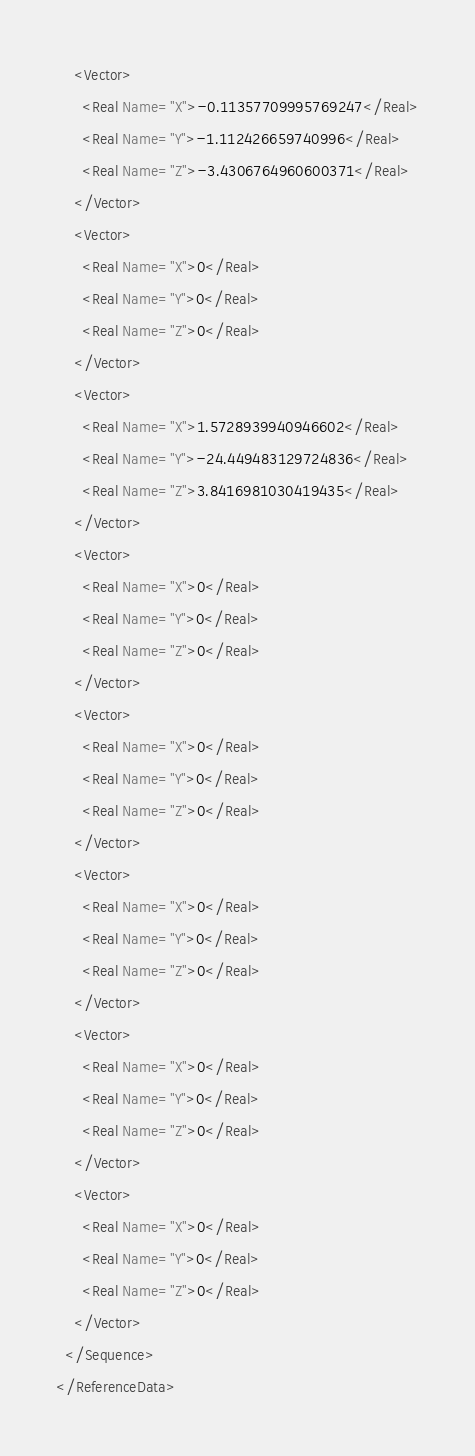Convert code to text. <code><loc_0><loc_0><loc_500><loc_500><_XML_>    <Vector>
      <Real Name="X">-0.11357709995769247</Real>
      <Real Name="Y">-1.112426659740996</Real>
      <Real Name="Z">-3.4306764960600371</Real>
    </Vector>
    <Vector>
      <Real Name="X">0</Real>
      <Real Name="Y">0</Real>
      <Real Name="Z">0</Real>
    </Vector>
    <Vector>
      <Real Name="X">1.5728939940946602</Real>
      <Real Name="Y">-24.449483129724836</Real>
      <Real Name="Z">3.8416981030419435</Real>
    </Vector>
    <Vector>
      <Real Name="X">0</Real>
      <Real Name="Y">0</Real>
      <Real Name="Z">0</Real>
    </Vector>
    <Vector>
      <Real Name="X">0</Real>
      <Real Name="Y">0</Real>
      <Real Name="Z">0</Real>
    </Vector>
    <Vector>
      <Real Name="X">0</Real>
      <Real Name="Y">0</Real>
      <Real Name="Z">0</Real>
    </Vector>
    <Vector>
      <Real Name="X">0</Real>
      <Real Name="Y">0</Real>
      <Real Name="Z">0</Real>
    </Vector>
    <Vector>
      <Real Name="X">0</Real>
      <Real Name="Y">0</Real>
      <Real Name="Z">0</Real>
    </Vector>
  </Sequence>
</ReferenceData>
</code> 